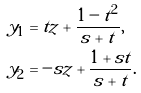Convert formula to latex. <formula><loc_0><loc_0><loc_500><loc_500>\tilde { y } _ { 1 } & = t z + \frac { 1 - t ^ { 2 } } { s + t } , \\ \tilde { y } _ { 2 } & = - s z + \frac { 1 + s t } { s + t } .</formula> 